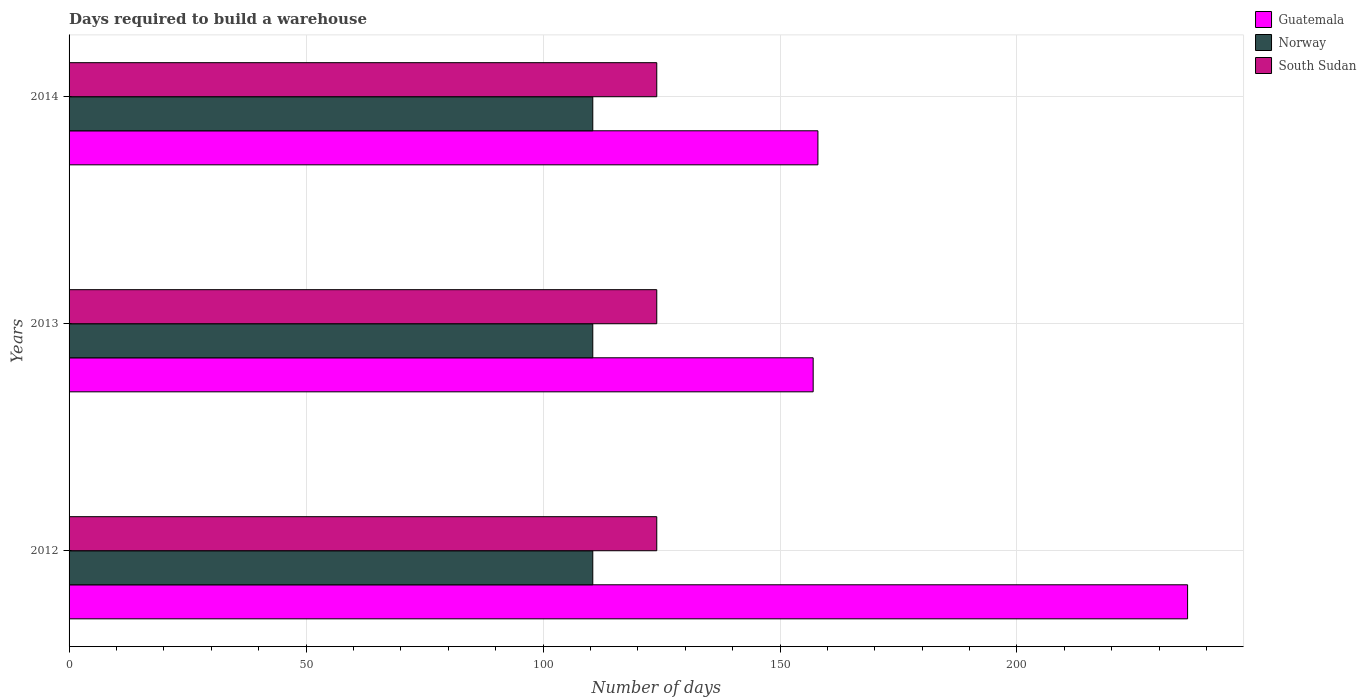Are the number of bars on each tick of the Y-axis equal?
Offer a terse response. Yes. How many bars are there on the 3rd tick from the bottom?
Ensure brevity in your answer.  3. In how many cases, is the number of bars for a given year not equal to the number of legend labels?
Give a very brief answer. 0. What is the days required to build a warehouse in in Guatemala in 2014?
Provide a short and direct response. 158. Across all years, what is the maximum days required to build a warehouse in in Guatemala?
Provide a short and direct response. 236. Across all years, what is the minimum days required to build a warehouse in in Norway?
Your answer should be compact. 110.5. In which year was the days required to build a warehouse in in South Sudan maximum?
Give a very brief answer. 2012. What is the total days required to build a warehouse in in Norway in the graph?
Ensure brevity in your answer.  331.5. What is the difference between the days required to build a warehouse in in Guatemala in 2012 and that in 2014?
Give a very brief answer. 78. What is the average days required to build a warehouse in in South Sudan per year?
Your answer should be very brief. 124. In the year 2013, what is the difference between the days required to build a warehouse in in Guatemala and days required to build a warehouse in in Norway?
Provide a succinct answer. 46.5. Is the difference between the days required to build a warehouse in in Guatemala in 2012 and 2014 greater than the difference between the days required to build a warehouse in in Norway in 2012 and 2014?
Keep it short and to the point. Yes. What is the difference between the highest and the lowest days required to build a warehouse in in Norway?
Your answer should be compact. 0. Is the sum of the days required to build a warehouse in in South Sudan in 2012 and 2013 greater than the maximum days required to build a warehouse in in Guatemala across all years?
Your answer should be compact. Yes. What does the 1st bar from the top in 2012 represents?
Your response must be concise. South Sudan. What does the 1st bar from the bottom in 2013 represents?
Make the answer very short. Guatemala. Is it the case that in every year, the sum of the days required to build a warehouse in in South Sudan and days required to build a warehouse in in Norway is greater than the days required to build a warehouse in in Guatemala?
Keep it short and to the point. No. How many bars are there?
Your answer should be compact. 9. Are all the bars in the graph horizontal?
Ensure brevity in your answer.  Yes. What is the difference between two consecutive major ticks on the X-axis?
Provide a short and direct response. 50. Does the graph contain any zero values?
Ensure brevity in your answer.  No. How are the legend labels stacked?
Provide a succinct answer. Vertical. What is the title of the graph?
Offer a very short reply. Days required to build a warehouse. Does "St. Vincent and the Grenadines" appear as one of the legend labels in the graph?
Ensure brevity in your answer.  No. What is the label or title of the X-axis?
Your answer should be very brief. Number of days. What is the label or title of the Y-axis?
Your answer should be very brief. Years. What is the Number of days in Guatemala in 2012?
Offer a terse response. 236. What is the Number of days of Norway in 2012?
Make the answer very short. 110.5. What is the Number of days in South Sudan in 2012?
Your response must be concise. 124. What is the Number of days in Guatemala in 2013?
Give a very brief answer. 157. What is the Number of days of Norway in 2013?
Offer a very short reply. 110.5. What is the Number of days in South Sudan in 2013?
Give a very brief answer. 124. What is the Number of days of Guatemala in 2014?
Offer a very short reply. 158. What is the Number of days of Norway in 2014?
Keep it short and to the point. 110.5. What is the Number of days of South Sudan in 2014?
Provide a short and direct response. 124. Across all years, what is the maximum Number of days in Guatemala?
Make the answer very short. 236. Across all years, what is the maximum Number of days of Norway?
Give a very brief answer. 110.5. Across all years, what is the maximum Number of days of South Sudan?
Your answer should be very brief. 124. Across all years, what is the minimum Number of days of Guatemala?
Provide a short and direct response. 157. Across all years, what is the minimum Number of days of Norway?
Ensure brevity in your answer.  110.5. Across all years, what is the minimum Number of days in South Sudan?
Your answer should be very brief. 124. What is the total Number of days of Guatemala in the graph?
Keep it short and to the point. 551. What is the total Number of days of Norway in the graph?
Your answer should be very brief. 331.5. What is the total Number of days of South Sudan in the graph?
Provide a short and direct response. 372. What is the difference between the Number of days in Guatemala in 2012 and that in 2013?
Your answer should be very brief. 79. What is the difference between the Number of days in Guatemala in 2012 and that in 2014?
Your answer should be very brief. 78. What is the difference between the Number of days in Norway in 2012 and that in 2014?
Make the answer very short. 0. What is the difference between the Number of days in South Sudan in 2012 and that in 2014?
Provide a short and direct response. 0. What is the difference between the Number of days in Guatemala in 2013 and that in 2014?
Your answer should be compact. -1. What is the difference between the Number of days in Norway in 2013 and that in 2014?
Offer a terse response. 0. What is the difference between the Number of days of South Sudan in 2013 and that in 2014?
Provide a short and direct response. 0. What is the difference between the Number of days of Guatemala in 2012 and the Number of days of Norway in 2013?
Offer a very short reply. 125.5. What is the difference between the Number of days of Guatemala in 2012 and the Number of days of South Sudan in 2013?
Ensure brevity in your answer.  112. What is the difference between the Number of days in Guatemala in 2012 and the Number of days in Norway in 2014?
Your answer should be compact. 125.5. What is the difference between the Number of days of Guatemala in 2012 and the Number of days of South Sudan in 2014?
Ensure brevity in your answer.  112. What is the difference between the Number of days in Norway in 2012 and the Number of days in South Sudan in 2014?
Provide a short and direct response. -13.5. What is the difference between the Number of days in Guatemala in 2013 and the Number of days in Norway in 2014?
Offer a very short reply. 46.5. What is the average Number of days in Guatemala per year?
Provide a succinct answer. 183.67. What is the average Number of days of Norway per year?
Offer a terse response. 110.5. What is the average Number of days in South Sudan per year?
Your answer should be compact. 124. In the year 2012, what is the difference between the Number of days of Guatemala and Number of days of Norway?
Your response must be concise. 125.5. In the year 2012, what is the difference between the Number of days in Guatemala and Number of days in South Sudan?
Offer a terse response. 112. In the year 2013, what is the difference between the Number of days in Guatemala and Number of days in Norway?
Keep it short and to the point. 46.5. In the year 2013, what is the difference between the Number of days in Guatemala and Number of days in South Sudan?
Keep it short and to the point. 33. In the year 2014, what is the difference between the Number of days of Guatemala and Number of days of Norway?
Your answer should be compact. 47.5. In the year 2014, what is the difference between the Number of days of Guatemala and Number of days of South Sudan?
Provide a short and direct response. 34. In the year 2014, what is the difference between the Number of days of Norway and Number of days of South Sudan?
Make the answer very short. -13.5. What is the ratio of the Number of days of Guatemala in 2012 to that in 2013?
Provide a short and direct response. 1.5. What is the ratio of the Number of days of Norway in 2012 to that in 2013?
Ensure brevity in your answer.  1. What is the ratio of the Number of days in South Sudan in 2012 to that in 2013?
Give a very brief answer. 1. What is the ratio of the Number of days in Guatemala in 2012 to that in 2014?
Offer a terse response. 1.49. What is the ratio of the Number of days in Norway in 2012 to that in 2014?
Give a very brief answer. 1. What is the ratio of the Number of days of South Sudan in 2012 to that in 2014?
Provide a succinct answer. 1. What is the ratio of the Number of days in Norway in 2013 to that in 2014?
Offer a terse response. 1. What is the difference between the highest and the second highest Number of days in South Sudan?
Provide a short and direct response. 0. What is the difference between the highest and the lowest Number of days of Guatemala?
Make the answer very short. 79. What is the difference between the highest and the lowest Number of days in South Sudan?
Your answer should be compact. 0. 